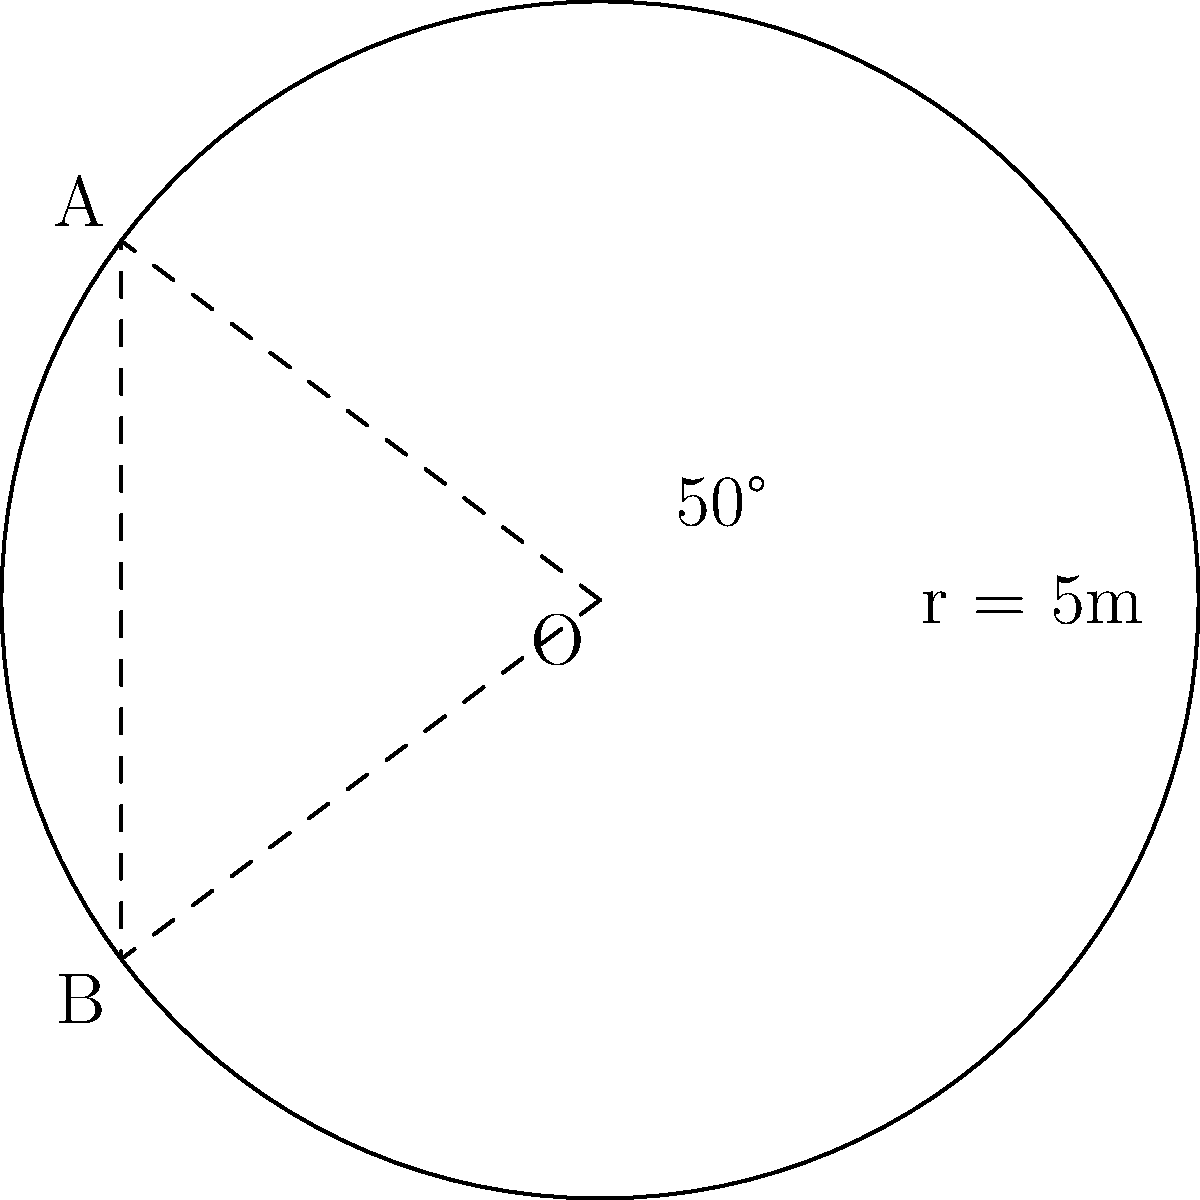During a Lipscomb track and field event, your child throws a discus that traces a circular path with a radius of 5 meters. The throw covers an angle of 50°. What is the area of the sector formed by this discus throw? Round your answer to the nearest square meter. To find the area of the sector, we'll follow these steps:

1) The formula for the area of a sector is:
   $$A = \frac{1}{2} r^2 \theta$$
   where $r$ is the radius and $\theta$ is the angle in radians.

2) We're given the radius $r = 5$ meters and the angle of 50°. However, we need to convert the angle to radians:
   $$\theta = 50° \times \frac{\pi}{180°} = \frac{5\pi}{18} \approx 0.8727 \text{ radians}$$

3) Now we can substitute these values into our formula:
   $$A = \frac{1}{2} \times 5^2 \times \frac{5\pi}{18}$$

4) Simplify:
   $$A = \frac{25 \times 5\pi}{36} = \frac{125\pi}{36} \approx 10.9 \text{ square meters}$$

5) Rounding to the nearest square meter:
   $$A \approx 11 \text{ square meters}$$
Answer: 11 square meters 